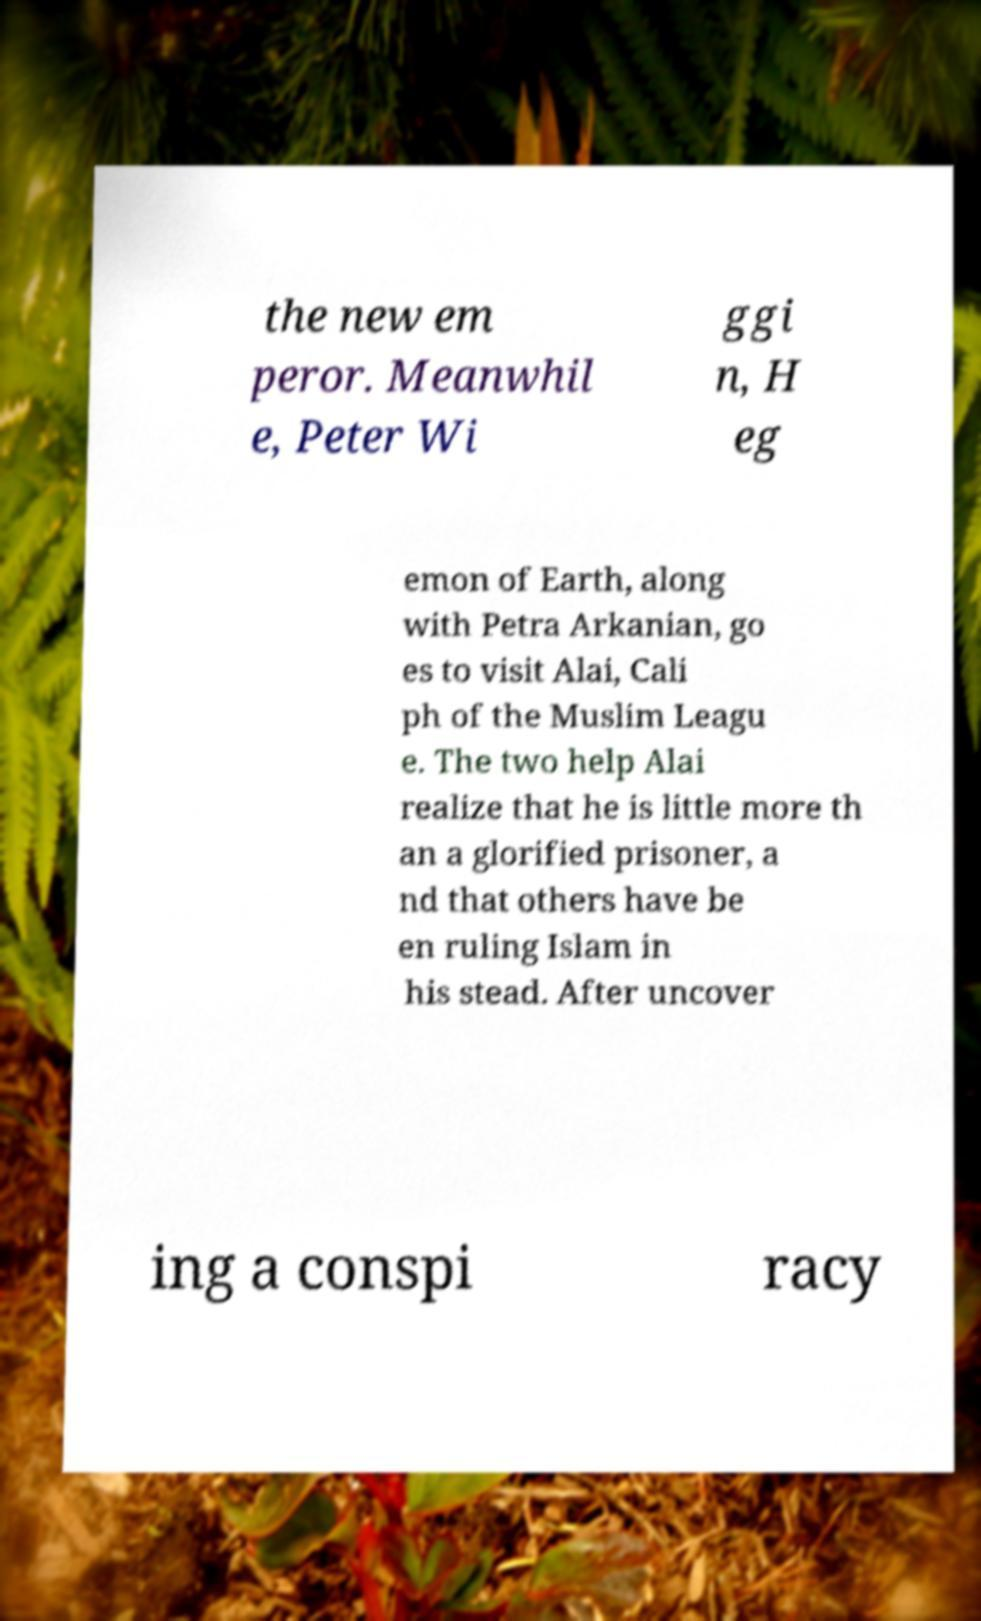Please read and relay the text visible in this image. What does it say? the new em peror. Meanwhil e, Peter Wi ggi n, H eg emon of Earth, along with Petra Arkanian, go es to visit Alai, Cali ph of the Muslim Leagu e. The two help Alai realize that he is little more th an a glorified prisoner, a nd that others have be en ruling Islam in his stead. After uncover ing a conspi racy 